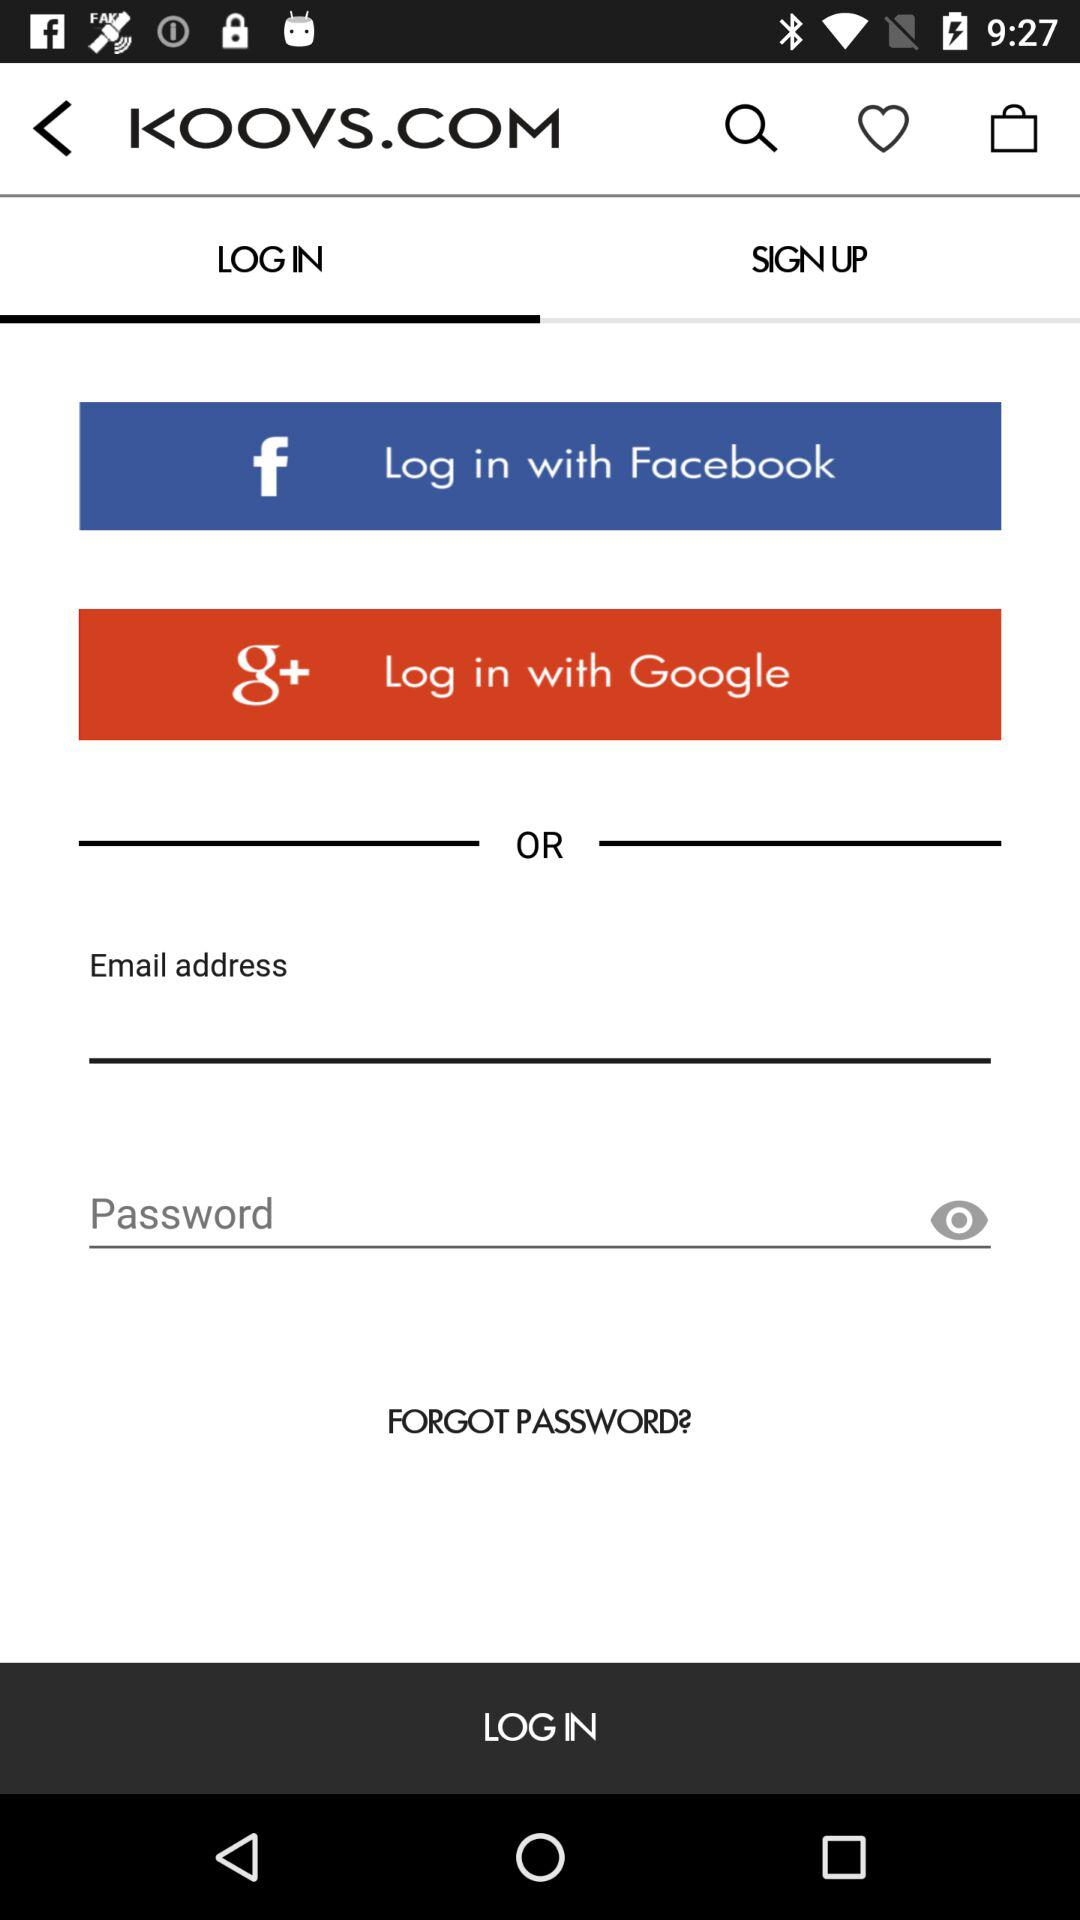What is the name of the application? The name of the application is "KOOVS". 